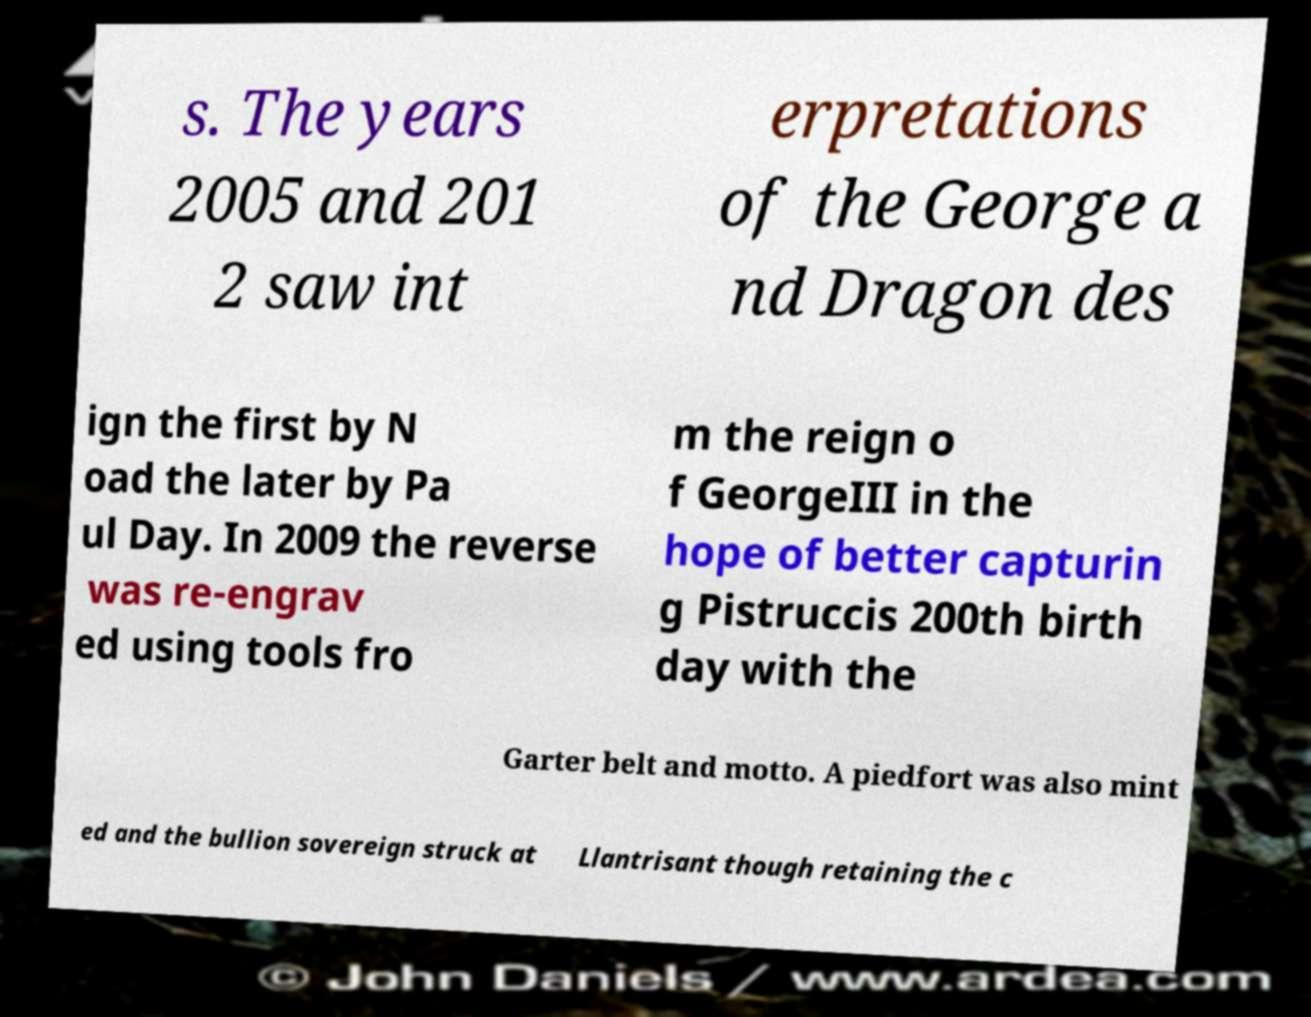What messages or text are displayed in this image? I need them in a readable, typed format. s. The years 2005 and 201 2 saw int erpretations of the George a nd Dragon des ign the first by N oad the later by Pa ul Day. In 2009 the reverse was re-engrav ed using tools fro m the reign o f GeorgeIII in the hope of better capturin g Pistruccis 200th birth day with the Garter belt and motto. A piedfort was also mint ed and the bullion sovereign struck at Llantrisant though retaining the c 